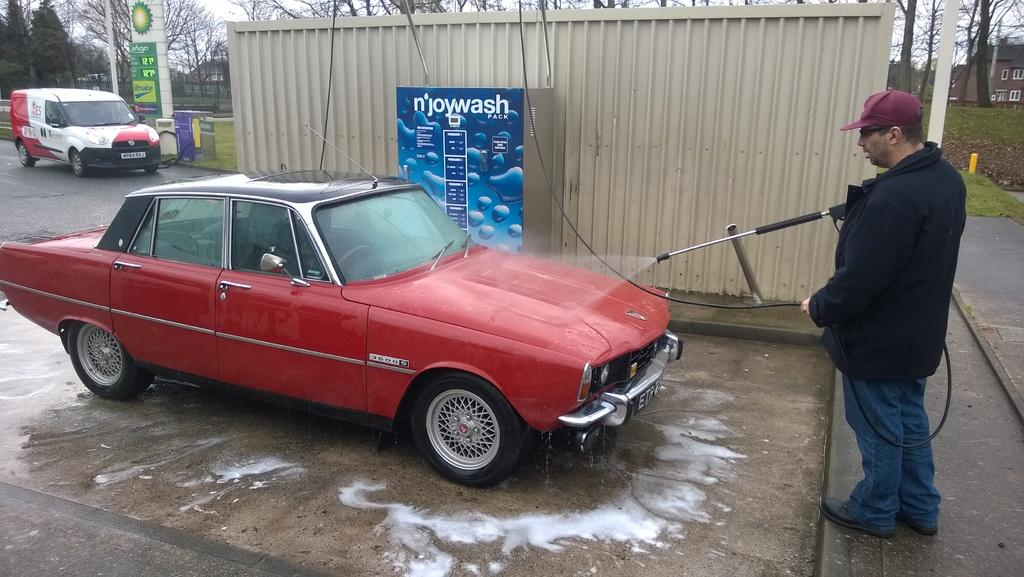What types of vehicles can be seen in the image? There are vehicles in the image, but the specific types are not mentioned. What is the person on the ground doing? The person on the ground is not performing any specific action in the image. What is located in the background of the image? In the background of the image, there is a container, houses, trees, the sky, and some unspecified objects. What type of badge is the person wearing in the image? There is no person wearing a badge in the image. What type of destruction can be seen in the image? There is no destruction present in the image. What type of bone is visible in the image? There are no bones visible in the image. 